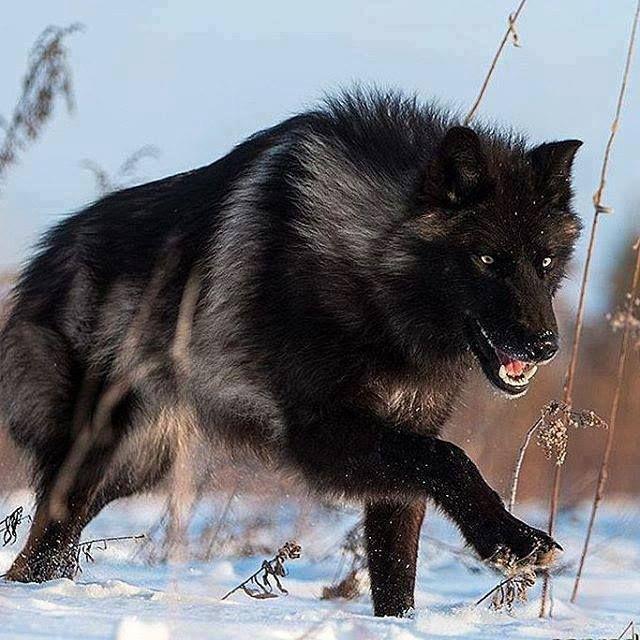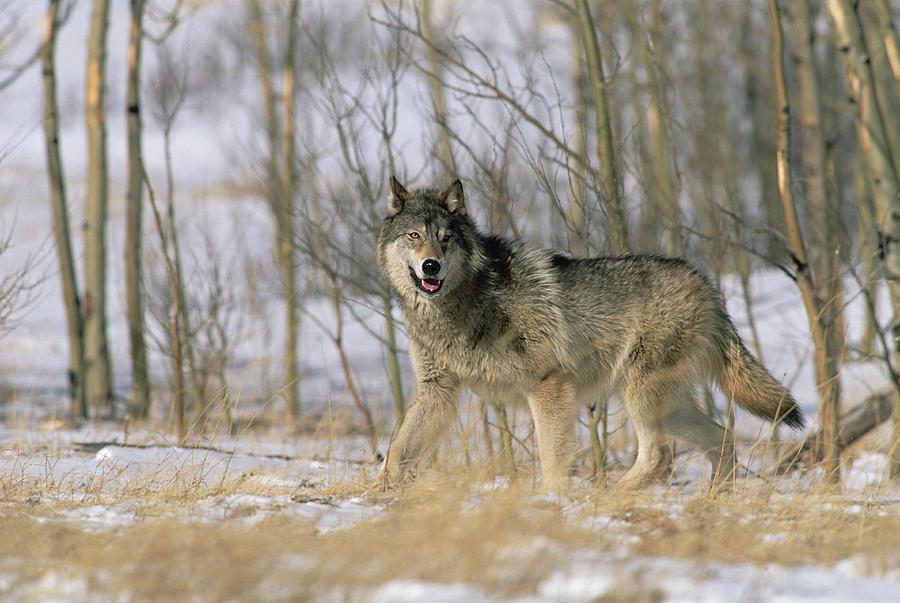The first image is the image on the left, the second image is the image on the right. For the images displayed, is the sentence "The animal in the image on the left is on snow." factually correct? Answer yes or no. Yes. 